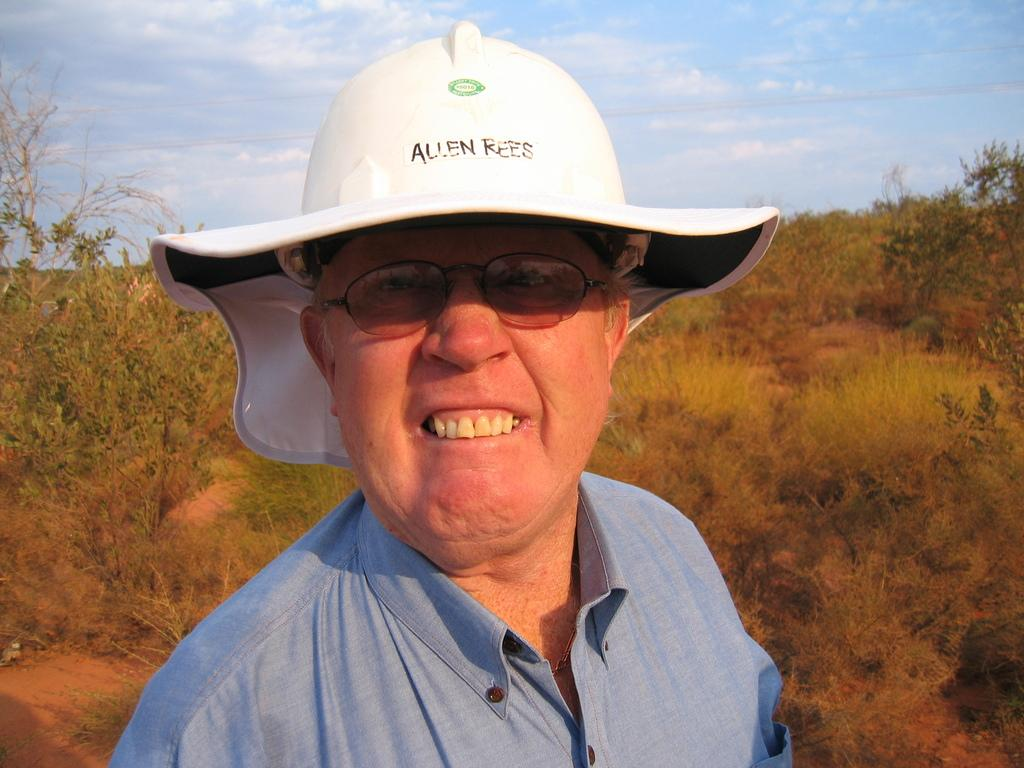What type of vegetation can be seen in the image? There are trees in the left and right corners of the image. Can you describe the man in the foreground? The man in the foreground is wearing a white cap, spectacles, and a blue shirt. What is visible at the top of the image? The sky is visible at the top of the image. What is the name of the division that the man is working for in the image? There is no information about the man's division or workplace in the image. How much debt does the man have, as shown in the image? There is no information about the man's debt in the image. 